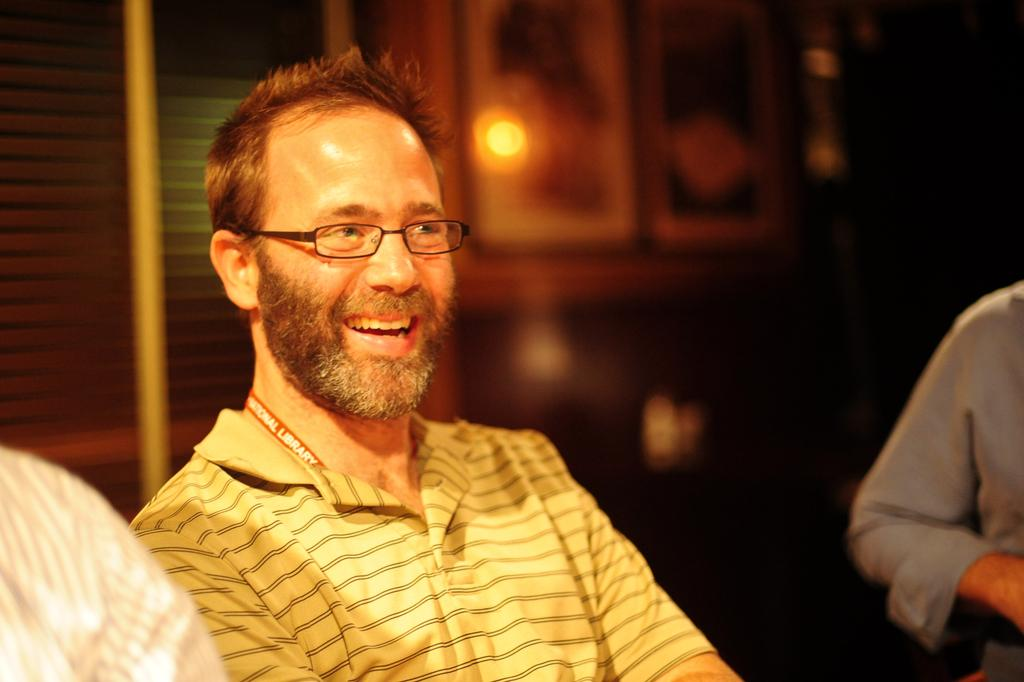What is the person in the image doing? The person is sitting in the image. What expression does the person have? The person is smiling. Can you describe the background of the image? The background of the image is blurred. What type of digestion issues is the person experiencing in the image? There is no indication of any digestion issues in the image; the person is simply sitting and smiling. How many rabbits can be seen in the image? There are no rabbits present in the image. 